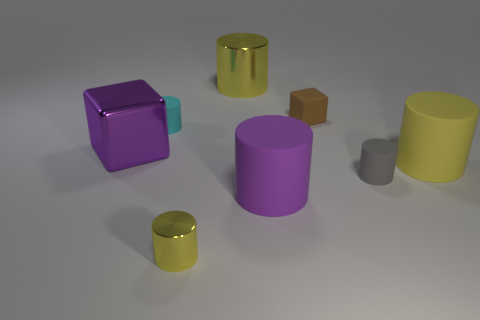There is a shiny object that is the same color as the large shiny cylinder; what size is it?
Provide a succinct answer. Small. What is the shape of the purple shiny thing?
Provide a succinct answer. Cube. Is the small metallic cylinder the same color as the big shiny cylinder?
Offer a very short reply. Yes. What is the color of the shiny cylinder that is the same size as the cyan matte cylinder?
Make the answer very short. Yellow. What number of purple things are shiny objects or tiny matte blocks?
Provide a succinct answer. 1. Is the number of tiny gray objects greater than the number of blue shiny objects?
Offer a terse response. Yes. There is a cyan rubber cylinder that is behind the tiny gray thing; does it have the same size as the rubber thing that is behind the tiny cyan object?
Your response must be concise. Yes. There is a big matte object that is to the left of the large cylinder to the right of the large purple thing right of the metallic block; what color is it?
Your response must be concise. Purple. Are there any big yellow things that have the same shape as the tiny gray rubber thing?
Keep it short and to the point. Yes. Is the number of tiny objects to the right of the brown rubber cube greater than the number of red metal objects?
Your answer should be compact. Yes. 